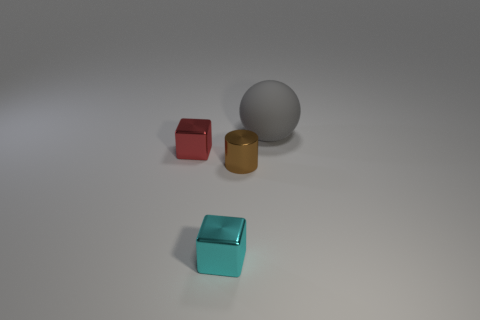Add 2 cyan cubes. How many objects exist? 6 Subtract all cylinders. How many objects are left? 3 Add 1 red blocks. How many red blocks exist? 2 Subtract 1 red blocks. How many objects are left? 3 Subtract all balls. Subtract all tiny brown metal cylinders. How many objects are left? 2 Add 4 cyan metal blocks. How many cyan metal blocks are left? 5 